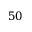<formula> <loc_0><loc_0><loc_500><loc_500>5 0</formula> 